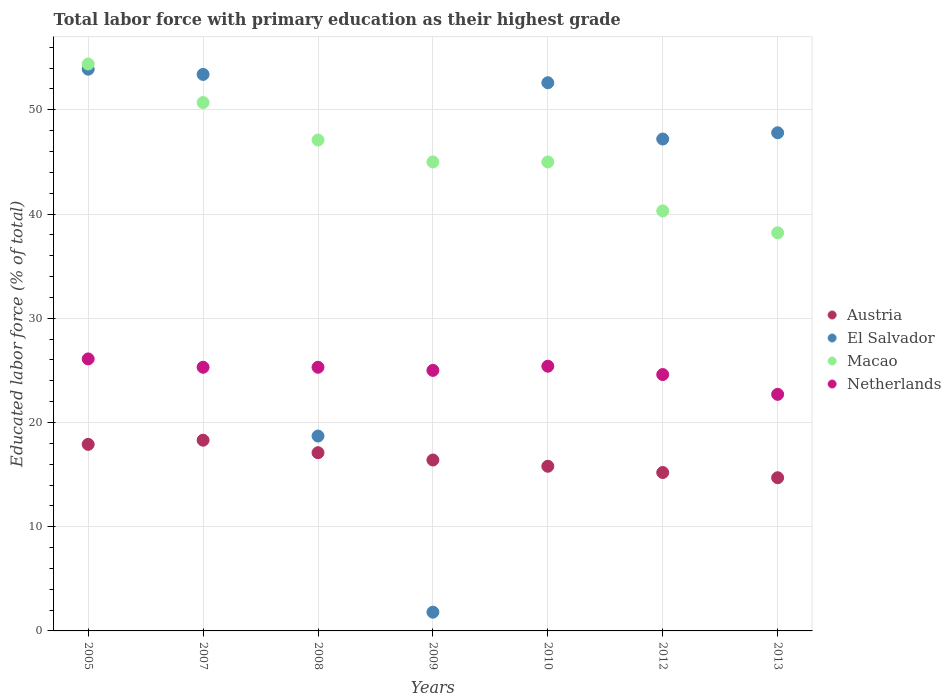Is the number of dotlines equal to the number of legend labels?
Your answer should be very brief. Yes. What is the percentage of total labor force with primary education in Netherlands in 2005?
Ensure brevity in your answer.  26.1. Across all years, what is the maximum percentage of total labor force with primary education in El Salvador?
Keep it short and to the point. 53.9. Across all years, what is the minimum percentage of total labor force with primary education in Netherlands?
Make the answer very short. 22.7. In which year was the percentage of total labor force with primary education in El Salvador maximum?
Ensure brevity in your answer.  2005. What is the total percentage of total labor force with primary education in Netherlands in the graph?
Make the answer very short. 174.4. What is the difference between the percentage of total labor force with primary education in Netherlands in 2007 and that in 2008?
Provide a short and direct response. 0. What is the difference between the percentage of total labor force with primary education in El Salvador in 2008 and the percentage of total labor force with primary education in Macao in 2012?
Your answer should be compact. -21.6. What is the average percentage of total labor force with primary education in Austria per year?
Your response must be concise. 16.49. In the year 2008, what is the difference between the percentage of total labor force with primary education in El Salvador and percentage of total labor force with primary education in Austria?
Your answer should be very brief. 1.6. In how many years, is the percentage of total labor force with primary education in Netherlands greater than 50 %?
Make the answer very short. 0. What is the ratio of the percentage of total labor force with primary education in Netherlands in 2009 to that in 2010?
Provide a short and direct response. 0.98. Is the difference between the percentage of total labor force with primary education in El Salvador in 2009 and 2012 greater than the difference between the percentage of total labor force with primary education in Austria in 2009 and 2012?
Offer a terse response. No. What is the difference between the highest and the second highest percentage of total labor force with primary education in Macao?
Provide a short and direct response. 3.7. What is the difference between the highest and the lowest percentage of total labor force with primary education in Macao?
Keep it short and to the point. 16.2. In how many years, is the percentage of total labor force with primary education in Netherlands greater than the average percentage of total labor force with primary education in Netherlands taken over all years?
Make the answer very short. 5. Is it the case that in every year, the sum of the percentage of total labor force with primary education in El Salvador and percentage of total labor force with primary education in Netherlands  is greater than the sum of percentage of total labor force with primary education in Austria and percentage of total labor force with primary education in Macao?
Offer a terse response. No. Is it the case that in every year, the sum of the percentage of total labor force with primary education in Austria and percentage of total labor force with primary education in Netherlands  is greater than the percentage of total labor force with primary education in El Salvador?
Ensure brevity in your answer.  No. How many dotlines are there?
Your response must be concise. 4. Does the graph contain any zero values?
Provide a succinct answer. No. Where does the legend appear in the graph?
Give a very brief answer. Center right. How are the legend labels stacked?
Your answer should be compact. Vertical. What is the title of the graph?
Ensure brevity in your answer.  Total labor force with primary education as their highest grade. What is the label or title of the Y-axis?
Offer a very short reply. Educated labor force (% of total). What is the Educated labor force (% of total) in Austria in 2005?
Your response must be concise. 17.9. What is the Educated labor force (% of total) in El Salvador in 2005?
Your response must be concise. 53.9. What is the Educated labor force (% of total) of Macao in 2005?
Keep it short and to the point. 54.4. What is the Educated labor force (% of total) of Netherlands in 2005?
Offer a terse response. 26.1. What is the Educated labor force (% of total) of Austria in 2007?
Ensure brevity in your answer.  18.3. What is the Educated labor force (% of total) of El Salvador in 2007?
Provide a short and direct response. 53.4. What is the Educated labor force (% of total) in Macao in 2007?
Your answer should be very brief. 50.7. What is the Educated labor force (% of total) in Netherlands in 2007?
Ensure brevity in your answer.  25.3. What is the Educated labor force (% of total) in Austria in 2008?
Provide a short and direct response. 17.1. What is the Educated labor force (% of total) of El Salvador in 2008?
Make the answer very short. 18.7. What is the Educated labor force (% of total) in Macao in 2008?
Give a very brief answer. 47.1. What is the Educated labor force (% of total) of Netherlands in 2008?
Provide a short and direct response. 25.3. What is the Educated labor force (% of total) of Austria in 2009?
Your response must be concise. 16.4. What is the Educated labor force (% of total) in El Salvador in 2009?
Offer a terse response. 1.8. What is the Educated labor force (% of total) in Austria in 2010?
Provide a short and direct response. 15.8. What is the Educated labor force (% of total) of El Salvador in 2010?
Provide a short and direct response. 52.6. What is the Educated labor force (% of total) of Macao in 2010?
Your response must be concise. 45. What is the Educated labor force (% of total) of Netherlands in 2010?
Ensure brevity in your answer.  25.4. What is the Educated labor force (% of total) of Austria in 2012?
Offer a terse response. 15.2. What is the Educated labor force (% of total) in El Salvador in 2012?
Your answer should be compact. 47.2. What is the Educated labor force (% of total) of Macao in 2012?
Your answer should be very brief. 40.3. What is the Educated labor force (% of total) in Netherlands in 2012?
Offer a very short reply. 24.6. What is the Educated labor force (% of total) in Austria in 2013?
Offer a terse response. 14.7. What is the Educated labor force (% of total) in El Salvador in 2013?
Your response must be concise. 47.8. What is the Educated labor force (% of total) of Macao in 2013?
Provide a short and direct response. 38.2. What is the Educated labor force (% of total) of Netherlands in 2013?
Give a very brief answer. 22.7. Across all years, what is the maximum Educated labor force (% of total) in Austria?
Provide a succinct answer. 18.3. Across all years, what is the maximum Educated labor force (% of total) of El Salvador?
Ensure brevity in your answer.  53.9. Across all years, what is the maximum Educated labor force (% of total) of Macao?
Offer a very short reply. 54.4. Across all years, what is the maximum Educated labor force (% of total) of Netherlands?
Give a very brief answer. 26.1. Across all years, what is the minimum Educated labor force (% of total) in Austria?
Offer a very short reply. 14.7. Across all years, what is the minimum Educated labor force (% of total) in El Salvador?
Your response must be concise. 1.8. Across all years, what is the minimum Educated labor force (% of total) in Macao?
Provide a short and direct response. 38.2. Across all years, what is the minimum Educated labor force (% of total) of Netherlands?
Provide a short and direct response. 22.7. What is the total Educated labor force (% of total) of Austria in the graph?
Provide a short and direct response. 115.4. What is the total Educated labor force (% of total) in El Salvador in the graph?
Your answer should be very brief. 275.4. What is the total Educated labor force (% of total) in Macao in the graph?
Give a very brief answer. 320.7. What is the total Educated labor force (% of total) in Netherlands in the graph?
Make the answer very short. 174.4. What is the difference between the Educated labor force (% of total) in El Salvador in 2005 and that in 2007?
Provide a succinct answer. 0.5. What is the difference between the Educated labor force (% of total) of Netherlands in 2005 and that in 2007?
Offer a terse response. 0.8. What is the difference between the Educated labor force (% of total) in El Salvador in 2005 and that in 2008?
Your answer should be very brief. 35.2. What is the difference between the Educated labor force (% of total) in Macao in 2005 and that in 2008?
Provide a succinct answer. 7.3. What is the difference between the Educated labor force (% of total) of El Salvador in 2005 and that in 2009?
Your answer should be very brief. 52.1. What is the difference between the Educated labor force (% of total) in Macao in 2005 and that in 2009?
Your answer should be very brief. 9.4. What is the difference between the Educated labor force (% of total) of Austria in 2005 and that in 2010?
Offer a terse response. 2.1. What is the difference between the Educated labor force (% of total) in Austria in 2005 and that in 2012?
Make the answer very short. 2.7. What is the difference between the Educated labor force (% of total) of Netherlands in 2005 and that in 2012?
Give a very brief answer. 1.5. What is the difference between the Educated labor force (% of total) of Austria in 2005 and that in 2013?
Your answer should be very brief. 3.2. What is the difference between the Educated labor force (% of total) in El Salvador in 2005 and that in 2013?
Offer a terse response. 6.1. What is the difference between the Educated labor force (% of total) of Macao in 2005 and that in 2013?
Keep it short and to the point. 16.2. What is the difference between the Educated labor force (% of total) of Netherlands in 2005 and that in 2013?
Keep it short and to the point. 3.4. What is the difference between the Educated labor force (% of total) of Austria in 2007 and that in 2008?
Your answer should be compact. 1.2. What is the difference between the Educated labor force (% of total) in El Salvador in 2007 and that in 2008?
Offer a very short reply. 34.7. What is the difference between the Educated labor force (% of total) in Macao in 2007 and that in 2008?
Keep it short and to the point. 3.6. What is the difference between the Educated labor force (% of total) of El Salvador in 2007 and that in 2009?
Offer a very short reply. 51.6. What is the difference between the Educated labor force (% of total) in Macao in 2007 and that in 2009?
Make the answer very short. 5.7. What is the difference between the Educated labor force (% of total) in El Salvador in 2007 and that in 2010?
Offer a terse response. 0.8. What is the difference between the Educated labor force (% of total) of El Salvador in 2007 and that in 2012?
Ensure brevity in your answer.  6.2. What is the difference between the Educated labor force (% of total) of Austria in 2007 and that in 2013?
Offer a terse response. 3.6. What is the difference between the Educated labor force (% of total) in El Salvador in 2007 and that in 2013?
Your answer should be very brief. 5.6. What is the difference between the Educated labor force (% of total) of Macao in 2007 and that in 2013?
Your answer should be very brief. 12.5. What is the difference between the Educated labor force (% of total) of Netherlands in 2007 and that in 2013?
Keep it short and to the point. 2.6. What is the difference between the Educated labor force (% of total) in Austria in 2008 and that in 2009?
Give a very brief answer. 0.7. What is the difference between the Educated labor force (% of total) of El Salvador in 2008 and that in 2009?
Provide a short and direct response. 16.9. What is the difference between the Educated labor force (% of total) in Macao in 2008 and that in 2009?
Keep it short and to the point. 2.1. What is the difference between the Educated labor force (% of total) of Netherlands in 2008 and that in 2009?
Ensure brevity in your answer.  0.3. What is the difference between the Educated labor force (% of total) in El Salvador in 2008 and that in 2010?
Offer a very short reply. -33.9. What is the difference between the Educated labor force (% of total) of El Salvador in 2008 and that in 2012?
Provide a succinct answer. -28.5. What is the difference between the Educated labor force (% of total) of Netherlands in 2008 and that in 2012?
Your response must be concise. 0.7. What is the difference between the Educated labor force (% of total) in Austria in 2008 and that in 2013?
Make the answer very short. 2.4. What is the difference between the Educated labor force (% of total) in El Salvador in 2008 and that in 2013?
Your response must be concise. -29.1. What is the difference between the Educated labor force (% of total) in Macao in 2008 and that in 2013?
Your response must be concise. 8.9. What is the difference between the Educated labor force (% of total) in Netherlands in 2008 and that in 2013?
Offer a very short reply. 2.6. What is the difference between the Educated labor force (% of total) in El Salvador in 2009 and that in 2010?
Your answer should be very brief. -50.8. What is the difference between the Educated labor force (% of total) of Austria in 2009 and that in 2012?
Give a very brief answer. 1.2. What is the difference between the Educated labor force (% of total) in El Salvador in 2009 and that in 2012?
Your answer should be very brief. -45.4. What is the difference between the Educated labor force (% of total) of Macao in 2009 and that in 2012?
Your response must be concise. 4.7. What is the difference between the Educated labor force (% of total) in Netherlands in 2009 and that in 2012?
Your response must be concise. 0.4. What is the difference between the Educated labor force (% of total) in Austria in 2009 and that in 2013?
Keep it short and to the point. 1.7. What is the difference between the Educated labor force (% of total) in El Salvador in 2009 and that in 2013?
Ensure brevity in your answer.  -46. What is the difference between the Educated labor force (% of total) of Austria in 2010 and that in 2012?
Provide a succinct answer. 0.6. What is the difference between the Educated labor force (% of total) of Netherlands in 2010 and that in 2013?
Your answer should be compact. 2.7. What is the difference between the Educated labor force (% of total) in Austria in 2012 and that in 2013?
Your response must be concise. 0.5. What is the difference between the Educated labor force (% of total) of El Salvador in 2012 and that in 2013?
Your answer should be very brief. -0.6. What is the difference between the Educated labor force (% of total) of Macao in 2012 and that in 2013?
Offer a terse response. 2.1. What is the difference between the Educated labor force (% of total) of Austria in 2005 and the Educated labor force (% of total) of El Salvador in 2007?
Offer a terse response. -35.5. What is the difference between the Educated labor force (% of total) in Austria in 2005 and the Educated labor force (% of total) in Macao in 2007?
Your response must be concise. -32.8. What is the difference between the Educated labor force (% of total) of El Salvador in 2005 and the Educated labor force (% of total) of Macao in 2007?
Provide a short and direct response. 3.2. What is the difference between the Educated labor force (% of total) in El Salvador in 2005 and the Educated labor force (% of total) in Netherlands in 2007?
Ensure brevity in your answer.  28.6. What is the difference between the Educated labor force (% of total) of Macao in 2005 and the Educated labor force (% of total) of Netherlands in 2007?
Give a very brief answer. 29.1. What is the difference between the Educated labor force (% of total) of Austria in 2005 and the Educated labor force (% of total) of El Salvador in 2008?
Make the answer very short. -0.8. What is the difference between the Educated labor force (% of total) in Austria in 2005 and the Educated labor force (% of total) in Macao in 2008?
Your answer should be compact. -29.2. What is the difference between the Educated labor force (% of total) in El Salvador in 2005 and the Educated labor force (% of total) in Netherlands in 2008?
Give a very brief answer. 28.6. What is the difference between the Educated labor force (% of total) of Macao in 2005 and the Educated labor force (% of total) of Netherlands in 2008?
Offer a very short reply. 29.1. What is the difference between the Educated labor force (% of total) of Austria in 2005 and the Educated labor force (% of total) of Macao in 2009?
Offer a terse response. -27.1. What is the difference between the Educated labor force (% of total) in El Salvador in 2005 and the Educated labor force (% of total) in Macao in 2009?
Offer a very short reply. 8.9. What is the difference between the Educated labor force (% of total) in El Salvador in 2005 and the Educated labor force (% of total) in Netherlands in 2009?
Offer a very short reply. 28.9. What is the difference between the Educated labor force (% of total) of Macao in 2005 and the Educated labor force (% of total) of Netherlands in 2009?
Make the answer very short. 29.4. What is the difference between the Educated labor force (% of total) of Austria in 2005 and the Educated labor force (% of total) of El Salvador in 2010?
Ensure brevity in your answer.  -34.7. What is the difference between the Educated labor force (% of total) of Austria in 2005 and the Educated labor force (% of total) of Macao in 2010?
Offer a very short reply. -27.1. What is the difference between the Educated labor force (% of total) of Macao in 2005 and the Educated labor force (% of total) of Netherlands in 2010?
Give a very brief answer. 29. What is the difference between the Educated labor force (% of total) of Austria in 2005 and the Educated labor force (% of total) of El Salvador in 2012?
Your response must be concise. -29.3. What is the difference between the Educated labor force (% of total) of Austria in 2005 and the Educated labor force (% of total) of Macao in 2012?
Provide a short and direct response. -22.4. What is the difference between the Educated labor force (% of total) of Austria in 2005 and the Educated labor force (% of total) of Netherlands in 2012?
Your response must be concise. -6.7. What is the difference between the Educated labor force (% of total) of El Salvador in 2005 and the Educated labor force (% of total) of Netherlands in 2012?
Your answer should be very brief. 29.3. What is the difference between the Educated labor force (% of total) of Macao in 2005 and the Educated labor force (% of total) of Netherlands in 2012?
Your answer should be compact. 29.8. What is the difference between the Educated labor force (% of total) of Austria in 2005 and the Educated labor force (% of total) of El Salvador in 2013?
Ensure brevity in your answer.  -29.9. What is the difference between the Educated labor force (% of total) in Austria in 2005 and the Educated labor force (% of total) in Macao in 2013?
Offer a terse response. -20.3. What is the difference between the Educated labor force (% of total) in El Salvador in 2005 and the Educated labor force (% of total) in Netherlands in 2013?
Keep it short and to the point. 31.2. What is the difference between the Educated labor force (% of total) of Macao in 2005 and the Educated labor force (% of total) of Netherlands in 2013?
Your answer should be compact. 31.7. What is the difference between the Educated labor force (% of total) in Austria in 2007 and the Educated labor force (% of total) in El Salvador in 2008?
Offer a very short reply. -0.4. What is the difference between the Educated labor force (% of total) in Austria in 2007 and the Educated labor force (% of total) in Macao in 2008?
Give a very brief answer. -28.8. What is the difference between the Educated labor force (% of total) of El Salvador in 2007 and the Educated labor force (% of total) of Macao in 2008?
Give a very brief answer. 6.3. What is the difference between the Educated labor force (% of total) in El Salvador in 2007 and the Educated labor force (% of total) in Netherlands in 2008?
Ensure brevity in your answer.  28.1. What is the difference between the Educated labor force (% of total) in Macao in 2007 and the Educated labor force (% of total) in Netherlands in 2008?
Your answer should be compact. 25.4. What is the difference between the Educated labor force (% of total) in Austria in 2007 and the Educated labor force (% of total) in El Salvador in 2009?
Your answer should be very brief. 16.5. What is the difference between the Educated labor force (% of total) of Austria in 2007 and the Educated labor force (% of total) of Macao in 2009?
Provide a succinct answer. -26.7. What is the difference between the Educated labor force (% of total) in El Salvador in 2007 and the Educated labor force (% of total) in Macao in 2009?
Offer a very short reply. 8.4. What is the difference between the Educated labor force (% of total) in El Salvador in 2007 and the Educated labor force (% of total) in Netherlands in 2009?
Keep it short and to the point. 28.4. What is the difference between the Educated labor force (% of total) of Macao in 2007 and the Educated labor force (% of total) of Netherlands in 2009?
Provide a succinct answer. 25.7. What is the difference between the Educated labor force (% of total) of Austria in 2007 and the Educated labor force (% of total) of El Salvador in 2010?
Offer a very short reply. -34.3. What is the difference between the Educated labor force (% of total) in Austria in 2007 and the Educated labor force (% of total) in Macao in 2010?
Your response must be concise. -26.7. What is the difference between the Educated labor force (% of total) in Austria in 2007 and the Educated labor force (% of total) in Netherlands in 2010?
Offer a terse response. -7.1. What is the difference between the Educated labor force (% of total) in Macao in 2007 and the Educated labor force (% of total) in Netherlands in 2010?
Provide a succinct answer. 25.3. What is the difference between the Educated labor force (% of total) in Austria in 2007 and the Educated labor force (% of total) in El Salvador in 2012?
Your answer should be compact. -28.9. What is the difference between the Educated labor force (% of total) in El Salvador in 2007 and the Educated labor force (% of total) in Netherlands in 2012?
Provide a succinct answer. 28.8. What is the difference between the Educated labor force (% of total) of Macao in 2007 and the Educated labor force (% of total) of Netherlands in 2012?
Give a very brief answer. 26.1. What is the difference between the Educated labor force (% of total) in Austria in 2007 and the Educated labor force (% of total) in El Salvador in 2013?
Your answer should be compact. -29.5. What is the difference between the Educated labor force (% of total) in Austria in 2007 and the Educated labor force (% of total) in Macao in 2013?
Your response must be concise. -19.9. What is the difference between the Educated labor force (% of total) in El Salvador in 2007 and the Educated labor force (% of total) in Macao in 2013?
Your answer should be compact. 15.2. What is the difference between the Educated labor force (% of total) in El Salvador in 2007 and the Educated labor force (% of total) in Netherlands in 2013?
Your answer should be very brief. 30.7. What is the difference between the Educated labor force (% of total) of Macao in 2007 and the Educated labor force (% of total) of Netherlands in 2013?
Offer a terse response. 28. What is the difference between the Educated labor force (% of total) of Austria in 2008 and the Educated labor force (% of total) of Macao in 2009?
Your response must be concise. -27.9. What is the difference between the Educated labor force (% of total) in Austria in 2008 and the Educated labor force (% of total) in Netherlands in 2009?
Provide a short and direct response. -7.9. What is the difference between the Educated labor force (% of total) of El Salvador in 2008 and the Educated labor force (% of total) of Macao in 2009?
Offer a very short reply. -26.3. What is the difference between the Educated labor force (% of total) in Macao in 2008 and the Educated labor force (% of total) in Netherlands in 2009?
Your response must be concise. 22.1. What is the difference between the Educated labor force (% of total) in Austria in 2008 and the Educated labor force (% of total) in El Salvador in 2010?
Your response must be concise. -35.5. What is the difference between the Educated labor force (% of total) of Austria in 2008 and the Educated labor force (% of total) of Macao in 2010?
Your answer should be compact. -27.9. What is the difference between the Educated labor force (% of total) of El Salvador in 2008 and the Educated labor force (% of total) of Macao in 2010?
Keep it short and to the point. -26.3. What is the difference between the Educated labor force (% of total) in Macao in 2008 and the Educated labor force (% of total) in Netherlands in 2010?
Provide a short and direct response. 21.7. What is the difference between the Educated labor force (% of total) of Austria in 2008 and the Educated labor force (% of total) of El Salvador in 2012?
Provide a succinct answer. -30.1. What is the difference between the Educated labor force (% of total) of Austria in 2008 and the Educated labor force (% of total) of Macao in 2012?
Ensure brevity in your answer.  -23.2. What is the difference between the Educated labor force (% of total) in El Salvador in 2008 and the Educated labor force (% of total) in Macao in 2012?
Offer a very short reply. -21.6. What is the difference between the Educated labor force (% of total) of El Salvador in 2008 and the Educated labor force (% of total) of Netherlands in 2012?
Offer a very short reply. -5.9. What is the difference between the Educated labor force (% of total) of Macao in 2008 and the Educated labor force (% of total) of Netherlands in 2012?
Ensure brevity in your answer.  22.5. What is the difference between the Educated labor force (% of total) in Austria in 2008 and the Educated labor force (% of total) in El Salvador in 2013?
Keep it short and to the point. -30.7. What is the difference between the Educated labor force (% of total) in Austria in 2008 and the Educated labor force (% of total) in Macao in 2013?
Your response must be concise. -21.1. What is the difference between the Educated labor force (% of total) in El Salvador in 2008 and the Educated labor force (% of total) in Macao in 2013?
Your answer should be very brief. -19.5. What is the difference between the Educated labor force (% of total) of Macao in 2008 and the Educated labor force (% of total) of Netherlands in 2013?
Your answer should be very brief. 24.4. What is the difference between the Educated labor force (% of total) in Austria in 2009 and the Educated labor force (% of total) in El Salvador in 2010?
Your answer should be compact. -36.2. What is the difference between the Educated labor force (% of total) of Austria in 2009 and the Educated labor force (% of total) of Macao in 2010?
Your response must be concise. -28.6. What is the difference between the Educated labor force (% of total) in El Salvador in 2009 and the Educated labor force (% of total) in Macao in 2010?
Ensure brevity in your answer.  -43.2. What is the difference between the Educated labor force (% of total) of El Salvador in 2009 and the Educated labor force (% of total) of Netherlands in 2010?
Your response must be concise. -23.6. What is the difference between the Educated labor force (% of total) of Macao in 2009 and the Educated labor force (% of total) of Netherlands in 2010?
Your response must be concise. 19.6. What is the difference between the Educated labor force (% of total) of Austria in 2009 and the Educated labor force (% of total) of El Salvador in 2012?
Keep it short and to the point. -30.8. What is the difference between the Educated labor force (% of total) in Austria in 2009 and the Educated labor force (% of total) in Macao in 2012?
Keep it short and to the point. -23.9. What is the difference between the Educated labor force (% of total) of El Salvador in 2009 and the Educated labor force (% of total) of Macao in 2012?
Offer a very short reply. -38.5. What is the difference between the Educated labor force (% of total) of El Salvador in 2009 and the Educated labor force (% of total) of Netherlands in 2012?
Your response must be concise. -22.8. What is the difference between the Educated labor force (% of total) of Macao in 2009 and the Educated labor force (% of total) of Netherlands in 2012?
Your answer should be very brief. 20.4. What is the difference between the Educated labor force (% of total) of Austria in 2009 and the Educated labor force (% of total) of El Salvador in 2013?
Keep it short and to the point. -31.4. What is the difference between the Educated labor force (% of total) of Austria in 2009 and the Educated labor force (% of total) of Macao in 2013?
Keep it short and to the point. -21.8. What is the difference between the Educated labor force (% of total) in El Salvador in 2009 and the Educated labor force (% of total) in Macao in 2013?
Your answer should be compact. -36.4. What is the difference between the Educated labor force (% of total) in El Salvador in 2009 and the Educated labor force (% of total) in Netherlands in 2013?
Your answer should be compact. -20.9. What is the difference between the Educated labor force (% of total) in Macao in 2009 and the Educated labor force (% of total) in Netherlands in 2013?
Make the answer very short. 22.3. What is the difference between the Educated labor force (% of total) in Austria in 2010 and the Educated labor force (% of total) in El Salvador in 2012?
Keep it short and to the point. -31.4. What is the difference between the Educated labor force (% of total) in Austria in 2010 and the Educated labor force (% of total) in Macao in 2012?
Provide a succinct answer. -24.5. What is the difference between the Educated labor force (% of total) of Austria in 2010 and the Educated labor force (% of total) of Netherlands in 2012?
Your answer should be very brief. -8.8. What is the difference between the Educated labor force (% of total) of Macao in 2010 and the Educated labor force (% of total) of Netherlands in 2012?
Offer a very short reply. 20.4. What is the difference between the Educated labor force (% of total) in Austria in 2010 and the Educated labor force (% of total) in El Salvador in 2013?
Keep it short and to the point. -32. What is the difference between the Educated labor force (% of total) of Austria in 2010 and the Educated labor force (% of total) of Macao in 2013?
Offer a terse response. -22.4. What is the difference between the Educated labor force (% of total) in El Salvador in 2010 and the Educated labor force (% of total) in Macao in 2013?
Ensure brevity in your answer.  14.4. What is the difference between the Educated labor force (% of total) of El Salvador in 2010 and the Educated labor force (% of total) of Netherlands in 2013?
Your answer should be compact. 29.9. What is the difference between the Educated labor force (% of total) of Macao in 2010 and the Educated labor force (% of total) of Netherlands in 2013?
Ensure brevity in your answer.  22.3. What is the difference between the Educated labor force (% of total) in Austria in 2012 and the Educated labor force (% of total) in El Salvador in 2013?
Give a very brief answer. -32.6. What is the average Educated labor force (% of total) in Austria per year?
Your answer should be compact. 16.49. What is the average Educated labor force (% of total) in El Salvador per year?
Your response must be concise. 39.34. What is the average Educated labor force (% of total) of Macao per year?
Provide a short and direct response. 45.81. What is the average Educated labor force (% of total) in Netherlands per year?
Make the answer very short. 24.91. In the year 2005, what is the difference between the Educated labor force (% of total) in Austria and Educated labor force (% of total) in El Salvador?
Your response must be concise. -36. In the year 2005, what is the difference between the Educated labor force (% of total) in Austria and Educated labor force (% of total) in Macao?
Your answer should be very brief. -36.5. In the year 2005, what is the difference between the Educated labor force (% of total) of El Salvador and Educated labor force (% of total) of Netherlands?
Make the answer very short. 27.8. In the year 2005, what is the difference between the Educated labor force (% of total) in Macao and Educated labor force (% of total) in Netherlands?
Ensure brevity in your answer.  28.3. In the year 2007, what is the difference between the Educated labor force (% of total) in Austria and Educated labor force (% of total) in El Salvador?
Give a very brief answer. -35.1. In the year 2007, what is the difference between the Educated labor force (% of total) of Austria and Educated labor force (% of total) of Macao?
Make the answer very short. -32.4. In the year 2007, what is the difference between the Educated labor force (% of total) of Austria and Educated labor force (% of total) of Netherlands?
Give a very brief answer. -7. In the year 2007, what is the difference between the Educated labor force (% of total) in El Salvador and Educated labor force (% of total) in Netherlands?
Make the answer very short. 28.1. In the year 2007, what is the difference between the Educated labor force (% of total) in Macao and Educated labor force (% of total) in Netherlands?
Ensure brevity in your answer.  25.4. In the year 2008, what is the difference between the Educated labor force (% of total) in Austria and Educated labor force (% of total) in El Salvador?
Your response must be concise. -1.6. In the year 2008, what is the difference between the Educated labor force (% of total) of El Salvador and Educated labor force (% of total) of Macao?
Provide a succinct answer. -28.4. In the year 2008, what is the difference between the Educated labor force (% of total) in Macao and Educated labor force (% of total) in Netherlands?
Ensure brevity in your answer.  21.8. In the year 2009, what is the difference between the Educated labor force (% of total) in Austria and Educated labor force (% of total) in El Salvador?
Ensure brevity in your answer.  14.6. In the year 2009, what is the difference between the Educated labor force (% of total) in Austria and Educated labor force (% of total) in Macao?
Provide a short and direct response. -28.6. In the year 2009, what is the difference between the Educated labor force (% of total) in El Salvador and Educated labor force (% of total) in Macao?
Keep it short and to the point. -43.2. In the year 2009, what is the difference between the Educated labor force (% of total) in El Salvador and Educated labor force (% of total) in Netherlands?
Your response must be concise. -23.2. In the year 2009, what is the difference between the Educated labor force (% of total) in Macao and Educated labor force (% of total) in Netherlands?
Your answer should be compact. 20. In the year 2010, what is the difference between the Educated labor force (% of total) in Austria and Educated labor force (% of total) in El Salvador?
Your response must be concise. -36.8. In the year 2010, what is the difference between the Educated labor force (% of total) of Austria and Educated labor force (% of total) of Macao?
Provide a short and direct response. -29.2. In the year 2010, what is the difference between the Educated labor force (% of total) of Austria and Educated labor force (% of total) of Netherlands?
Provide a short and direct response. -9.6. In the year 2010, what is the difference between the Educated labor force (% of total) in El Salvador and Educated labor force (% of total) in Netherlands?
Make the answer very short. 27.2. In the year 2010, what is the difference between the Educated labor force (% of total) of Macao and Educated labor force (% of total) of Netherlands?
Keep it short and to the point. 19.6. In the year 2012, what is the difference between the Educated labor force (% of total) of Austria and Educated labor force (% of total) of El Salvador?
Offer a terse response. -32. In the year 2012, what is the difference between the Educated labor force (% of total) of Austria and Educated labor force (% of total) of Macao?
Provide a succinct answer. -25.1. In the year 2012, what is the difference between the Educated labor force (% of total) in El Salvador and Educated labor force (% of total) in Macao?
Your response must be concise. 6.9. In the year 2012, what is the difference between the Educated labor force (% of total) in El Salvador and Educated labor force (% of total) in Netherlands?
Make the answer very short. 22.6. In the year 2012, what is the difference between the Educated labor force (% of total) of Macao and Educated labor force (% of total) of Netherlands?
Ensure brevity in your answer.  15.7. In the year 2013, what is the difference between the Educated labor force (% of total) of Austria and Educated labor force (% of total) of El Salvador?
Offer a very short reply. -33.1. In the year 2013, what is the difference between the Educated labor force (% of total) in Austria and Educated labor force (% of total) in Macao?
Offer a terse response. -23.5. In the year 2013, what is the difference between the Educated labor force (% of total) of El Salvador and Educated labor force (% of total) of Netherlands?
Your answer should be compact. 25.1. In the year 2013, what is the difference between the Educated labor force (% of total) in Macao and Educated labor force (% of total) in Netherlands?
Make the answer very short. 15.5. What is the ratio of the Educated labor force (% of total) in Austria in 2005 to that in 2007?
Your answer should be compact. 0.98. What is the ratio of the Educated labor force (% of total) in El Salvador in 2005 to that in 2007?
Your answer should be very brief. 1.01. What is the ratio of the Educated labor force (% of total) of Macao in 2005 to that in 2007?
Offer a terse response. 1.07. What is the ratio of the Educated labor force (% of total) in Netherlands in 2005 to that in 2007?
Your answer should be very brief. 1.03. What is the ratio of the Educated labor force (% of total) in Austria in 2005 to that in 2008?
Keep it short and to the point. 1.05. What is the ratio of the Educated labor force (% of total) in El Salvador in 2005 to that in 2008?
Your response must be concise. 2.88. What is the ratio of the Educated labor force (% of total) in Macao in 2005 to that in 2008?
Keep it short and to the point. 1.16. What is the ratio of the Educated labor force (% of total) in Netherlands in 2005 to that in 2008?
Ensure brevity in your answer.  1.03. What is the ratio of the Educated labor force (% of total) of Austria in 2005 to that in 2009?
Provide a short and direct response. 1.09. What is the ratio of the Educated labor force (% of total) of El Salvador in 2005 to that in 2009?
Your response must be concise. 29.94. What is the ratio of the Educated labor force (% of total) in Macao in 2005 to that in 2009?
Keep it short and to the point. 1.21. What is the ratio of the Educated labor force (% of total) of Netherlands in 2005 to that in 2009?
Make the answer very short. 1.04. What is the ratio of the Educated labor force (% of total) in Austria in 2005 to that in 2010?
Provide a succinct answer. 1.13. What is the ratio of the Educated labor force (% of total) in El Salvador in 2005 to that in 2010?
Your response must be concise. 1.02. What is the ratio of the Educated labor force (% of total) in Macao in 2005 to that in 2010?
Give a very brief answer. 1.21. What is the ratio of the Educated labor force (% of total) of Netherlands in 2005 to that in 2010?
Give a very brief answer. 1.03. What is the ratio of the Educated labor force (% of total) in Austria in 2005 to that in 2012?
Provide a short and direct response. 1.18. What is the ratio of the Educated labor force (% of total) of El Salvador in 2005 to that in 2012?
Provide a succinct answer. 1.14. What is the ratio of the Educated labor force (% of total) in Macao in 2005 to that in 2012?
Give a very brief answer. 1.35. What is the ratio of the Educated labor force (% of total) in Netherlands in 2005 to that in 2012?
Ensure brevity in your answer.  1.06. What is the ratio of the Educated labor force (% of total) in Austria in 2005 to that in 2013?
Your answer should be very brief. 1.22. What is the ratio of the Educated labor force (% of total) of El Salvador in 2005 to that in 2013?
Keep it short and to the point. 1.13. What is the ratio of the Educated labor force (% of total) in Macao in 2005 to that in 2013?
Provide a short and direct response. 1.42. What is the ratio of the Educated labor force (% of total) in Netherlands in 2005 to that in 2013?
Ensure brevity in your answer.  1.15. What is the ratio of the Educated labor force (% of total) in Austria in 2007 to that in 2008?
Make the answer very short. 1.07. What is the ratio of the Educated labor force (% of total) in El Salvador in 2007 to that in 2008?
Make the answer very short. 2.86. What is the ratio of the Educated labor force (% of total) in Macao in 2007 to that in 2008?
Offer a terse response. 1.08. What is the ratio of the Educated labor force (% of total) in Netherlands in 2007 to that in 2008?
Your answer should be very brief. 1. What is the ratio of the Educated labor force (% of total) in Austria in 2007 to that in 2009?
Offer a very short reply. 1.12. What is the ratio of the Educated labor force (% of total) in El Salvador in 2007 to that in 2009?
Provide a short and direct response. 29.67. What is the ratio of the Educated labor force (% of total) of Macao in 2007 to that in 2009?
Your answer should be compact. 1.13. What is the ratio of the Educated labor force (% of total) in Austria in 2007 to that in 2010?
Your answer should be very brief. 1.16. What is the ratio of the Educated labor force (% of total) of El Salvador in 2007 to that in 2010?
Make the answer very short. 1.02. What is the ratio of the Educated labor force (% of total) of Macao in 2007 to that in 2010?
Give a very brief answer. 1.13. What is the ratio of the Educated labor force (% of total) in Austria in 2007 to that in 2012?
Give a very brief answer. 1.2. What is the ratio of the Educated labor force (% of total) in El Salvador in 2007 to that in 2012?
Provide a short and direct response. 1.13. What is the ratio of the Educated labor force (% of total) of Macao in 2007 to that in 2012?
Provide a succinct answer. 1.26. What is the ratio of the Educated labor force (% of total) of Netherlands in 2007 to that in 2012?
Your answer should be compact. 1.03. What is the ratio of the Educated labor force (% of total) of Austria in 2007 to that in 2013?
Provide a succinct answer. 1.24. What is the ratio of the Educated labor force (% of total) of El Salvador in 2007 to that in 2013?
Give a very brief answer. 1.12. What is the ratio of the Educated labor force (% of total) in Macao in 2007 to that in 2013?
Provide a succinct answer. 1.33. What is the ratio of the Educated labor force (% of total) of Netherlands in 2007 to that in 2013?
Your answer should be very brief. 1.11. What is the ratio of the Educated labor force (% of total) in Austria in 2008 to that in 2009?
Provide a succinct answer. 1.04. What is the ratio of the Educated labor force (% of total) of El Salvador in 2008 to that in 2009?
Provide a short and direct response. 10.39. What is the ratio of the Educated labor force (% of total) in Macao in 2008 to that in 2009?
Your answer should be compact. 1.05. What is the ratio of the Educated labor force (% of total) in Netherlands in 2008 to that in 2009?
Offer a terse response. 1.01. What is the ratio of the Educated labor force (% of total) of Austria in 2008 to that in 2010?
Offer a very short reply. 1.08. What is the ratio of the Educated labor force (% of total) of El Salvador in 2008 to that in 2010?
Your answer should be compact. 0.36. What is the ratio of the Educated labor force (% of total) of Macao in 2008 to that in 2010?
Provide a succinct answer. 1.05. What is the ratio of the Educated labor force (% of total) in El Salvador in 2008 to that in 2012?
Provide a short and direct response. 0.4. What is the ratio of the Educated labor force (% of total) in Macao in 2008 to that in 2012?
Offer a very short reply. 1.17. What is the ratio of the Educated labor force (% of total) in Netherlands in 2008 to that in 2012?
Your response must be concise. 1.03. What is the ratio of the Educated labor force (% of total) in Austria in 2008 to that in 2013?
Your answer should be compact. 1.16. What is the ratio of the Educated labor force (% of total) in El Salvador in 2008 to that in 2013?
Your response must be concise. 0.39. What is the ratio of the Educated labor force (% of total) of Macao in 2008 to that in 2013?
Your answer should be compact. 1.23. What is the ratio of the Educated labor force (% of total) of Netherlands in 2008 to that in 2013?
Give a very brief answer. 1.11. What is the ratio of the Educated labor force (% of total) of Austria in 2009 to that in 2010?
Ensure brevity in your answer.  1.04. What is the ratio of the Educated labor force (% of total) in El Salvador in 2009 to that in 2010?
Make the answer very short. 0.03. What is the ratio of the Educated labor force (% of total) in Netherlands in 2009 to that in 2010?
Your answer should be compact. 0.98. What is the ratio of the Educated labor force (% of total) in Austria in 2009 to that in 2012?
Offer a very short reply. 1.08. What is the ratio of the Educated labor force (% of total) in El Salvador in 2009 to that in 2012?
Provide a short and direct response. 0.04. What is the ratio of the Educated labor force (% of total) of Macao in 2009 to that in 2012?
Offer a terse response. 1.12. What is the ratio of the Educated labor force (% of total) in Netherlands in 2009 to that in 2012?
Your answer should be compact. 1.02. What is the ratio of the Educated labor force (% of total) of Austria in 2009 to that in 2013?
Provide a succinct answer. 1.12. What is the ratio of the Educated labor force (% of total) in El Salvador in 2009 to that in 2013?
Ensure brevity in your answer.  0.04. What is the ratio of the Educated labor force (% of total) in Macao in 2009 to that in 2013?
Your answer should be compact. 1.18. What is the ratio of the Educated labor force (% of total) in Netherlands in 2009 to that in 2013?
Your answer should be very brief. 1.1. What is the ratio of the Educated labor force (% of total) in Austria in 2010 to that in 2012?
Give a very brief answer. 1.04. What is the ratio of the Educated labor force (% of total) of El Salvador in 2010 to that in 2012?
Provide a succinct answer. 1.11. What is the ratio of the Educated labor force (% of total) in Macao in 2010 to that in 2012?
Offer a very short reply. 1.12. What is the ratio of the Educated labor force (% of total) in Netherlands in 2010 to that in 2012?
Provide a short and direct response. 1.03. What is the ratio of the Educated labor force (% of total) in Austria in 2010 to that in 2013?
Provide a succinct answer. 1.07. What is the ratio of the Educated labor force (% of total) in El Salvador in 2010 to that in 2013?
Your answer should be compact. 1.1. What is the ratio of the Educated labor force (% of total) of Macao in 2010 to that in 2013?
Give a very brief answer. 1.18. What is the ratio of the Educated labor force (% of total) of Netherlands in 2010 to that in 2013?
Your response must be concise. 1.12. What is the ratio of the Educated labor force (% of total) of Austria in 2012 to that in 2013?
Your answer should be compact. 1.03. What is the ratio of the Educated labor force (% of total) of El Salvador in 2012 to that in 2013?
Keep it short and to the point. 0.99. What is the ratio of the Educated labor force (% of total) in Macao in 2012 to that in 2013?
Your answer should be compact. 1.05. What is the ratio of the Educated labor force (% of total) in Netherlands in 2012 to that in 2013?
Ensure brevity in your answer.  1.08. What is the difference between the highest and the second highest Educated labor force (% of total) of El Salvador?
Provide a succinct answer. 0.5. What is the difference between the highest and the lowest Educated labor force (% of total) of El Salvador?
Your answer should be compact. 52.1. What is the difference between the highest and the lowest Educated labor force (% of total) in Macao?
Provide a succinct answer. 16.2. What is the difference between the highest and the lowest Educated labor force (% of total) in Netherlands?
Offer a very short reply. 3.4. 